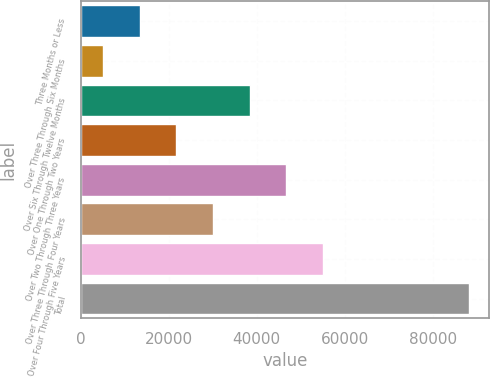Convert chart. <chart><loc_0><loc_0><loc_500><loc_500><bar_chart><fcel>Three Months or Less<fcel>Over Three Through Six Months<fcel>Over Six Through Twelve Months<fcel>Over One Through Two Years<fcel>Over Two Through Three Years<fcel>Over Three Through Four Years<fcel>Over Four Through Five Years<fcel>Total<nl><fcel>13421.9<fcel>5098<fcel>38393.6<fcel>21745.8<fcel>46717.5<fcel>30069.7<fcel>55041.4<fcel>88337<nl></chart> 